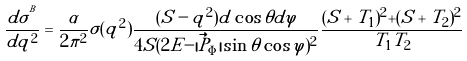Convert formula to latex. <formula><loc_0><loc_0><loc_500><loc_500>\frac { d \sigma ^ { ^ { B } } } { d q ^ { 2 } } = \frac { \alpha } { 2 \pi ^ { 2 } } \sigma ( q ^ { 2 } ) \frac { ( S - q ^ { 2 } ) d \cos { \theta } d \varphi } { 4 S ( 2 E - | \vec { P } _ { \Phi } | \sin { \theta } \cos { \varphi } ) ^ { 2 } } \frac { ( S + T _ { 1 } ) ^ { 2 } + ( S + T _ { 2 } ) ^ { 2 } } { T _ { 1 } T _ { 2 } }</formula> 